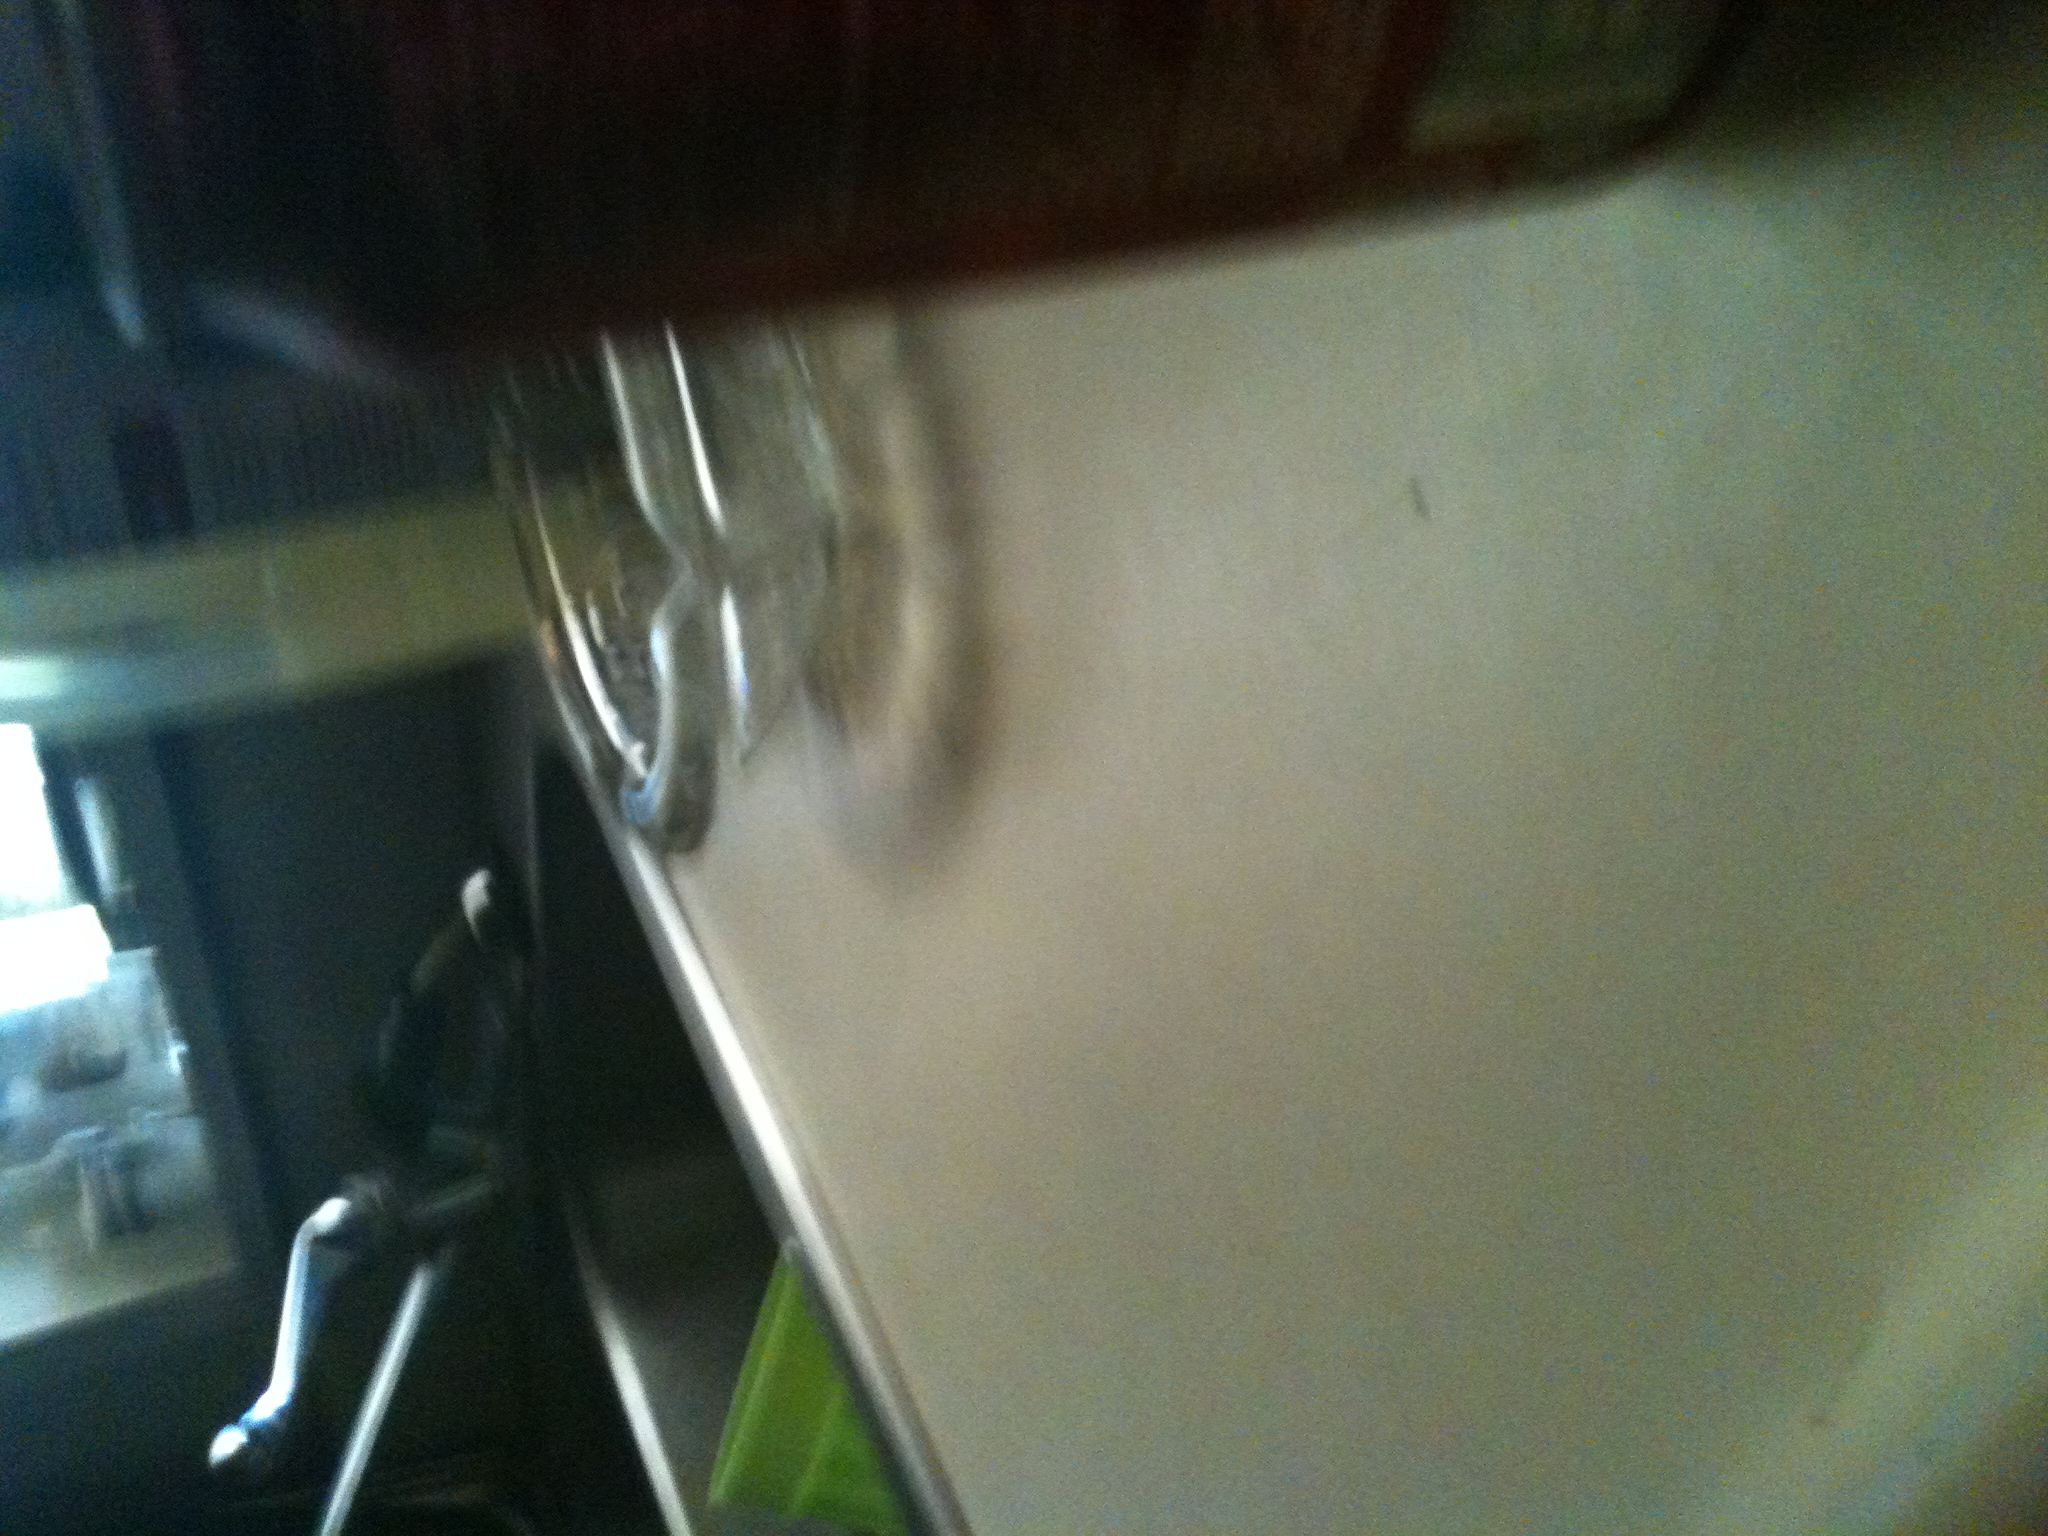Is there any other object that can provide context about this environment or the drink? There's an ashtray next to the can, placed on the countertop. This may suggest that the surrounding area is either a home or an indoor area where smoking is permitted, perhaps offering insights into the social setting or habits of the inhabitants. What can you infer about the lighting conditions in the image? The lighting in the image is dim and indirect, typical of an indoor setting, possibly lit by ambient light from nearby windows or artificial light, emphasizing a casual, unstructured environment. 